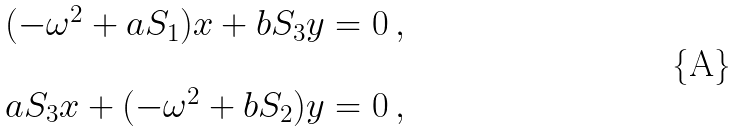<formula> <loc_0><loc_0><loc_500><loc_500>\begin{array} { c } ( - \omega ^ { 2 } + a S _ { 1 } ) x + b S _ { 3 } y = 0 \, , \\ \\ a S _ { 3 } x + ( - \omega ^ { 2 } + b S _ { 2 } ) y = 0 \, , \end{array}</formula> 